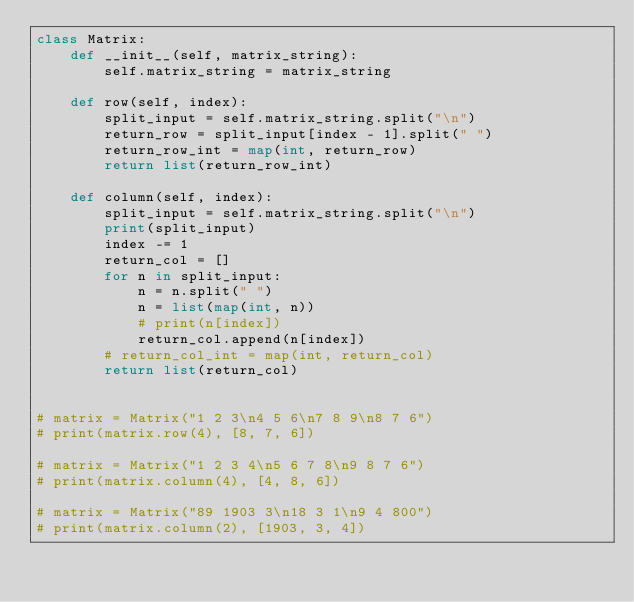Convert code to text. <code><loc_0><loc_0><loc_500><loc_500><_Python_>class Matrix:
    def __init__(self, matrix_string):
        self.matrix_string = matrix_string

    def row(self, index):
        split_input = self.matrix_string.split("\n")
        return_row = split_input[index - 1].split(" ")
        return_row_int = map(int, return_row)
        return list(return_row_int)

    def column(self, index):
        split_input = self.matrix_string.split("\n")
        print(split_input)
        index -= 1
        return_col = []
        for n in split_input:
            n = n.split(" ")
            n = list(map(int, n))
            # print(n[index])
            return_col.append(n[index])
        # return_col_int = map(int, return_col)
        return list(return_col)


# matrix = Matrix("1 2 3\n4 5 6\n7 8 9\n8 7 6")
# print(matrix.row(4), [8, 7, 6])

# matrix = Matrix("1 2 3 4\n5 6 7 8\n9 8 7 6")
# print(matrix.column(4), [4, 8, 6])

# matrix = Matrix("89 1903 3\n18 3 1\n9 4 800")
# print(matrix.column(2), [1903, 3, 4])
</code> 